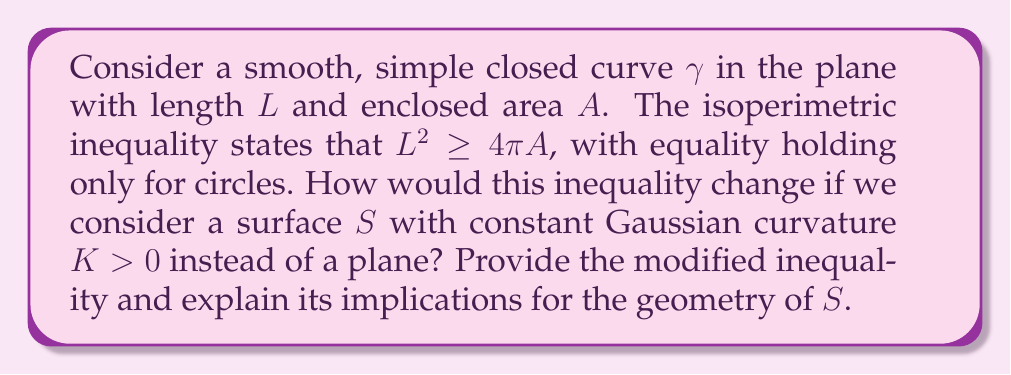Could you help me with this problem? To solve this problem, we need to consider the following steps:

1) First, recall that the isoperimetric inequality in the plane is:

   $$L^2 \geq 4\pi A$$

2) On a surface with constant positive Gaussian curvature $K$, this inequality is modified. The general form is:

   $$L^2 \geq 4\pi A - KA^2$$

3) This modification is known as the Levy-Gromov isoperimetric inequality for surfaces of constant positive curvature.

4) To understand the implications, let's analyze this inequality:

   a) When $K = 0$, we recover the original isoperimetric inequality for the plane.

   b) As $K$ increases, the right-hand side of the inequality decreases, allowing for curves with smaller perimeter to enclose the same area.

5) This reflects the fact that on positively curved surfaces, geodesics (the equivalent of straight lines) tend to converge, making it easier to enclose areas.

6) The equality case for this inequality occurs for geodesic circles on the surface.

7) An important implication is that on a sphere (which has constant positive curvature), small circles behave similarly to circles in the plane, but large circles have a smaller perimeter relative to their enclosed area compared to planar circles.

8) This inequality also puts an upper bound on the area that can be enclosed by a curve of given length on the surface:

   $$A \leq \frac{2\pi}{K}\left(1 - \sqrt{1 - \frac{KL^2}{4\pi^2}}\right)$$

9) This upper bound approaches $\frac{2\pi}{K}$ as $L$ increases, which is half the total area of a sphere with curvature $K$. This reflects the fact that on a sphere, a curve can enclose at most half of the total surface area.
Answer: $L^2 \geq 4\pi A - KA^2$, where $K > 0$ is the constant Gaussian curvature of the surface. 